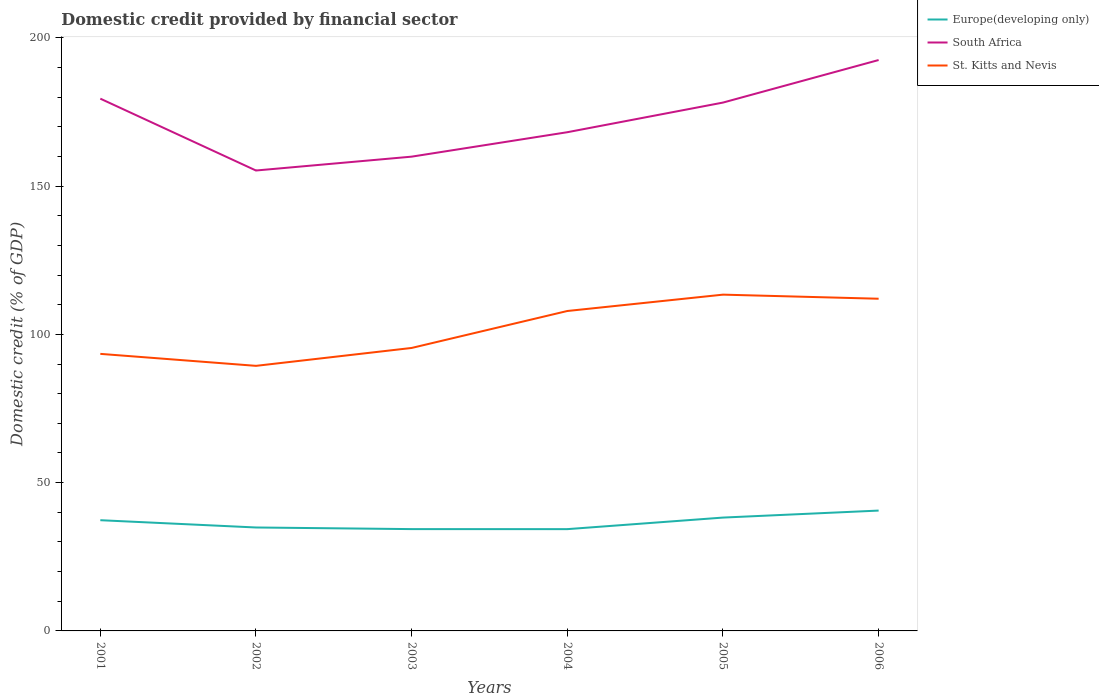Is the number of lines equal to the number of legend labels?
Keep it short and to the point. Yes. Across all years, what is the maximum domestic credit in St. Kitts and Nevis?
Your answer should be very brief. 89.38. What is the total domestic credit in St. Kitts and Nevis in the graph?
Provide a succinct answer. 4.04. What is the difference between the highest and the second highest domestic credit in South Africa?
Your answer should be compact. 37.25. What is the difference between the highest and the lowest domestic credit in Europe(developing only)?
Make the answer very short. 3. Is the domestic credit in Europe(developing only) strictly greater than the domestic credit in St. Kitts and Nevis over the years?
Offer a terse response. Yes. How many years are there in the graph?
Offer a terse response. 6. Are the values on the major ticks of Y-axis written in scientific E-notation?
Your answer should be very brief. No. How many legend labels are there?
Your answer should be compact. 3. What is the title of the graph?
Make the answer very short. Domestic credit provided by financial sector. Does "Niger" appear as one of the legend labels in the graph?
Your answer should be very brief. No. What is the label or title of the X-axis?
Keep it short and to the point. Years. What is the label or title of the Y-axis?
Make the answer very short. Domestic credit (% of GDP). What is the Domestic credit (% of GDP) of Europe(developing only) in 2001?
Your answer should be very brief. 37.33. What is the Domestic credit (% of GDP) of South Africa in 2001?
Offer a terse response. 179.48. What is the Domestic credit (% of GDP) in St. Kitts and Nevis in 2001?
Your response must be concise. 93.42. What is the Domestic credit (% of GDP) in Europe(developing only) in 2002?
Your answer should be very brief. 34.88. What is the Domestic credit (% of GDP) in South Africa in 2002?
Your answer should be compact. 155.25. What is the Domestic credit (% of GDP) in St. Kitts and Nevis in 2002?
Provide a succinct answer. 89.38. What is the Domestic credit (% of GDP) of Europe(developing only) in 2003?
Offer a terse response. 34.33. What is the Domestic credit (% of GDP) in South Africa in 2003?
Make the answer very short. 159.92. What is the Domestic credit (% of GDP) in St. Kitts and Nevis in 2003?
Make the answer very short. 95.42. What is the Domestic credit (% of GDP) in Europe(developing only) in 2004?
Provide a short and direct response. 34.32. What is the Domestic credit (% of GDP) of South Africa in 2004?
Make the answer very short. 168.16. What is the Domestic credit (% of GDP) of St. Kitts and Nevis in 2004?
Offer a terse response. 107.88. What is the Domestic credit (% of GDP) in Europe(developing only) in 2005?
Keep it short and to the point. 38.22. What is the Domestic credit (% of GDP) of South Africa in 2005?
Give a very brief answer. 178.16. What is the Domestic credit (% of GDP) of St. Kitts and Nevis in 2005?
Make the answer very short. 113.39. What is the Domestic credit (% of GDP) of Europe(developing only) in 2006?
Offer a terse response. 40.58. What is the Domestic credit (% of GDP) of South Africa in 2006?
Offer a terse response. 192.5. What is the Domestic credit (% of GDP) of St. Kitts and Nevis in 2006?
Offer a very short reply. 112.01. Across all years, what is the maximum Domestic credit (% of GDP) in Europe(developing only)?
Your answer should be very brief. 40.58. Across all years, what is the maximum Domestic credit (% of GDP) in South Africa?
Provide a short and direct response. 192.5. Across all years, what is the maximum Domestic credit (% of GDP) of St. Kitts and Nevis?
Offer a terse response. 113.39. Across all years, what is the minimum Domestic credit (% of GDP) in Europe(developing only)?
Your answer should be compact. 34.32. Across all years, what is the minimum Domestic credit (% of GDP) of South Africa?
Offer a terse response. 155.25. Across all years, what is the minimum Domestic credit (% of GDP) of St. Kitts and Nevis?
Make the answer very short. 89.38. What is the total Domestic credit (% of GDP) in Europe(developing only) in the graph?
Offer a very short reply. 219.66. What is the total Domestic credit (% of GDP) of South Africa in the graph?
Your response must be concise. 1033.47. What is the total Domestic credit (% of GDP) in St. Kitts and Nevis in the graph?
Make the answer very short. 611.5. What is the difference between the Domestic credit (% of GDP) of Europe(developing only) in 2001 and that in 2002?
Offer a terse response. 2.46. What is the difference between the Domestic credit (% of GDP) of South Africa in 2001 and that in 2002?
Your answer should be very brief. 24.23. What is the difference between the Domestic credit (% of GDP) in St. Kitts and Nevis in 2001 and that in 2002?
Your answer should be compact. 4.04. What is the difference between the Domestic credit (% of GDP) in Europe(developing only) in 2001 and that in 2003?
Your answer should be very brief. 3. What is the difference between the Domestic credit (% of GDP) of South Africa in 2001 and that in 2003?
Offer a very short reply. 19.55. What is the difference between the Domestic credit (% of GDP) in St. Kitts and Nevis in 2001 and that in 2003?
Ensure brevity in your answer.  -1.99. What is the difference between the Domestic credit (% of GDP) in Europe(developing only) in 2001 and that in 2004?
Your answer should be very brief. 3.01. What is the difference between the Domestic credit (% of GDP) of South Africa in 2001 and that in 2004?
Give a very brief answer. 11.32. What is the difference between the Domestic credit (% of GDP) in St. Kitts and Nevis in 2001 and that in 2004?
Offer a very short reply. -14.45. What is the difference between the Domestic credit (% of GDP) of Europe(developing only) in 2001 and that in 2005?
Provide a short and direct response. -0.88. What is the difference between the Domestic credit (% of GDP) in South Africa in 2001 and that in 2005?
Provide a succinct answer. 1.32. What is the difference between the Domestic credit (% of GDP) in St. Kitts and Nevis in 2001 and that in 2005?
Offer a very short reply. -19.97. What is the difference between the Domestic credit (% of GDP) of Europe(developing only) in 2001 and that in 2006?
Your answer should be compact. -3.24. What is the difference between the Domestic credit (% of GDP) of South Africa in 2001 and that in 2006?
Provide a succinct answer. -13.03. What is the difference between the Domestic credit (% of GDP) of St. Kitts and Nevis in 2001 and that in 2006?
Your response must be concise. -18.59. What is the difference between the Domestic credit (% of GDP) in Europe(developing only) in 2002 and that in 2003?
Keep it short and to the point. 0.55. What is the difference between the Domestic credit (% of GDP) of South Africa in 2002 and that in 2003?
Keep it short and to the point. -4.67. What is the difference between the Domestic credit (% of GDP) in St. Kitts and Nevis in 2002 and that in 2003?
Offer a terse response. -6.03. What is the difference between the Domestic credit (% of GDP) of Europe(developing only) in 2002 and that in 2004?
Make the answer very short. 0.56. What is the difference between the Domestic credit (% of GDP) of South Africa in 2002 and that in 2004?
Your answer should be compact. -12.91. What is the difference between the Domestic credit (% of GDP) of St. Kitts and Nevis in 2002 and that in 2004?
Provide a short and direct response. -18.49. What is the difference between the Domestic credit (% of GDP) of Europe(developing only) in 2002 and that in 2005?
Your answer should be very brief. -3.34. What is the difference between the Domestic credit (% of GDP) in South Africa in 2002 and that in 2005?
Offer a very short reply. -22.91. What is the difference between the Domestic credit (% of GDP) in St. Kitts and Nevis in 2002 and that in 2005?
Your answer should be very brief. -24.01. What is the difference between the Domestic credit (% of GDP) of Europe(developing only) in 2002 and that in 2006?
Make the answer very short. -5.7. What is the difference between the Domestic credit (% of GDP) of South Africa in 2002 and that in 2006?
Offer a terse response. -37.25. What is the difference between the Domestic credit (% of GDP) in St. Kitts and Nevis in 2002 and that in 2006?
Offer a terse response. -22.63. What is the difference between the Domestic credit (% of GDP) in Europe(developing only) in 2003 and that in 2004?
Offer a terse response. 0.01. What is the difference between the Domestic credit (% of GDP) of South Africa in 2003 and that in 2004?
Make the answer very short. -8.24. What is the difference between the Domestic credit (% of GDP) in St. Kitts and Nevis in 2003 and that in 2004?
Offer a very short reply. -12.46. What is the difference between the Domestic credit (% of GDP) of Europe(developing only) in 2003 and that in 2005?
Make the answer very short. -3.89. What is the difference between the Domestic credit (% of GDP) in South Africa in 2003 and that in 2005?
Keep it short and to the point. -18.23. What is the difference between the Domestic credit (% of GDP) of St. Kitts and Nevis in 2003 and that in 2005?
Your response must be concise. -17.97. What is the difference between the Domestic credit (% of GDP) of Europe(developing only) in 2003 and that in 2006?
Ensure brevity in your answer.  -6.25. What is the difference between the Domestic credit (% of GDP) in South Africa in 2003 and that in 2006?
Keep it short and to the point. -32.58. What is the difference between the Domestic credit (% of GDP) of St. Kitts and Nevis in 2003 and that in 2006?
Your answer should be very brief. -16.59. What is the difference between the Domestic credit (% of GDP) of Europe(developing only) in 2004 and that in 2005?
Your answer should be very brief. -3.9. What is the difference between the Domestic credit (% of GDP) in South Africa in 2004 and that in 2005?
Keep it short and to the point. -10. What is the difference between the Domestic credit (% of GDP) of St. Kitts and Nevis in 2004 and that in 2005?
Ensure brevity in your answer.  -5.51. What is the difference between the Domestic credit (% of GDP) in Europe(developing only) in 2004 and that in 2006?
Provide a short and direct response. -6.26. What is the difference between the Domestic credit (% of GDP) in South Africa in 2004 and that in 2006?
Provide a short and direct response. -24.34. What is the difference between the Domestic credit (% of GDP) in St. Kitts and Nevis in 2004 and that in 2006?
Your response must be concise. -4.13. What is the difference between the Domestic credit (% of GDP) in Europe(developing only) in 2005 and that in 2006?
Your response must be concise. -2.36. What is the difference between the Domestic credit (% of GDP) in South Africa in 2005 and that in 2006?
Offer a very short reply. -14.35. What is the difference between the Domestic credit (% of GDP) of St. Kitts and Nevis in 2005 and that in 2006?
Your response must be concise. 1.38. What is the difference between the Domestic credit (% of GDP) in Europe(developing only) in 2001 and the Domestic credit (% of GDP) in South Africa in 2002?
Ensure brevity in your answer.  -117.91. What is the difference between the Domestic credit (% of GDP) in Europe(developing only) in 2001 and the Domestic credit (% of GDP) in St. Kitts and Nevis in 2002?
Keep it short and to the point. -52.05. What is the difference between the Domestic credit (% of GDP) of South Africa in 2001 and the Domestic credit (% of GDP) of St. Kitts and Nevis in 2002?
Keep it short and to the point. 90.09. What is the difference between the Domestic credit (% of GDP) in Europe(developing only) in 2001 and the Domestic credit (% of GDP) in South Africa in 2003?
Offer a very short reply. -122.59. What is the difference between the Domestic credit (% of GDP) in Europe(developing only) in 2001 and the Domestic credit (% of GDP) in St. Kitts and Nevis in 2003?
Your answer should be compact. -58.08. What is the difference between the Domestic credit (% of GDP) of South Africa in 2001 and the Domestic credit (% of GDP) of St. Kitts and Nevis in 2003?
Keep it short and to the point. 84.06. What is the difference between the Domestic credit (% of GDP) in Europe(developing only) in 2001 and the Domestic credit (% of GDP) in South Africa in 2004?
Offer a very short reply. -130.83. What is the difference between the Domestic credit (% of GDP) in Europe(developing only) in 2001 and the Domestic credit (% of GDP) in St. Kitts and Nevis in 2004?
Provide a short and direct response. -70.54. What is the difference between the Domestic credit (% of GDP) of South Africa in 2001 and the Domestic credit (% of GDP) of St. Kitts and Nevis in 2004?
Give a very brief answer. 71.6. What is the difference between the Domestic credit (% of GDP) in Europe(developing only) in 2001 and the Domestic credit (% of GDP) in South Africa in 2005?
Keep it short and to the point. -140.82. What is the difference between the Domestic credit (% of GDP) of Europe(developing only) in 2001 and the Domestic credit (% of GDP) of St. Kitts and Nevis in 2005?
Your response must be concise. -76.06. What is the difference between the Domestic credit (% of GDP) in South Africa in 2001 and the Domestic credit (% of GDP) in St. Kitts and Nevis in 2005?
Offer a very short reply. 66.09. What is the difference between the Domestic credit (% of GDP) of Europe(developing only) in 2001 and the Domestic credit (% of GDP) of South Africa in 2006?
Keep it short and to the point. -155.17. What is the difference between the Domestic credit (% of GDP) in Europe(developing only) in 2001 and the Domestic credit (% of GDP) in St. Kitts and Nevis in 2006?
Keep it short and to the point. -74.68. What is the difference between the Domestic credit (% of GDP) of South Africa in 2001 and the Domestic credit (% of GDP) of St. Kitts and Nevis in 2006?
Offer a terse response. 67.47. What is the difference between the Domestic credit (% of GDP) in Europe(developing only) in 2002 and the Domestic credit (% of GDP) in South Africa in 2003?
Your response must be concise. -125.05. What is the difference between the Domestic credit (% of GDP) in Europe(developing only) in 2002 and the Domestic credit (% of GDP) in St. Kitts and Nevis in 2003?
Ensure brevity in your answer.  -60.54. What is the difference between the Domestic credit (% of GDP) in South Africa in 2002 and the Domestic credit (% of GDP) in St. Kitts and Nevis in 2003?
Keep it short and to the point. 59.83. What is the difference between the Domestic credit (% of GDP) in Europe(developing only) in 2002 and the Domestic credit (% of GDP) in South Africa in 2004?
Your answer should be compact. -133.28. What is the difference between the Domestic credit (% of GDP) in Europe(developing only) in 2002 and the Domestic credit (% of GDP) in St. Kitts and Nevis in 2004?
Offer a very short reply. -73. What is the difference between the Domestic credit (% of GDP) in South Africa in 2002 and the Domestic credit (% of GDP) in St. Kitts and Nevis in 2004?
Keep it short and to the point. 47.37. What is the difference between the Domestic credit (% of GDP) in Europe(developing only) in 2002 and the Domestic credit (% of GDP) in South Africa in 2005?
Provide a short and direct response. -143.28. What is the difference between the Domestic credit (% of GDP) of Europe(developing only) in 2002 and the Domestic credit (% of GDP) of St. Kitts and Nevis in 2005?
Provide a short and direct response. -78.51. What is the difference between the Domestic credit (% of GDP) in South Africa in 2002 and the Domestic credit (% of GDP) in St. Kitts and Nevis in 2005?
Your response must be concise. 41.86. What is the difference between the Domestic credit (% of GDP) of Europe(developing only) in 2002 and the Domestic credit (% of GDP) of South Africa in 2006?
Make the answer very short. -157.63. What is the difference between the Domestic credit (% of GDP) in Europe(developing only) in 2002 and the Domestic credit (% of GDP) in St. Kitts and Nevis in 2006?
Your answer should be very brief. -77.13. What is the difference between the Domestic credit (% of GDP) in South Africa in 2002 and the Domestic credit (% of GDP) in St. Kitts and Nevis in 2006?
Your answer should be compact. 43.24. What is the difference between the Domestic credit (% of GDP) of Europe(developing only) in 2003 and the Domestic credit (% of GDP) of South Africa in 2004?
Your answer should be compact. -133.83. What is the difference between the Domestic credit (% of GDP) in Europe(developing only) in 2003 and the Domestic credit (% of GDP) in St. Kitts and Nevis in 2004?
Provide a short and direct response. -73.54. What is the difference between the Domestic credit (% of GDP) of South Africa in 2003 and the Domestic credit (% of GDP) of St. Kitts and Nevis in 2004?
Make the answer very short. 52.05. What is the difference between the Domestic credit (% of GDP) of Europe(developing only) in 2003 and the Domestic credit (% of GDP) of South Africa in 2005?
Give a very brief answer. -143.82. What is the difference between the Domestic credit (% of GDP) of Europe(developing only) in 2003 and the Domestic credit (% of GDP) of St. Kitts and Nevis in 2005?
Offer a very short reply. -79.06. What is the difference between the Domestic credit (% of GDP) of South Africa in 2003 and the Domestic credit (% of GDP) of St. Kitts and Nevis in 2005?
Offer a very short reply. 46.53. What is the difference between the Domestic credit (% of GDP) of Europe(developing only) in 2003 and the Domestic credit (% of GDP) of South Africa in 2006?
Make the answer very short. -158.17. What is the difference between the Domestic credit (% of GDP) in Europe(developing only) in 2003 and the Domestic credit (% of GDP) in St. Kitts and Nevis in 2006?
Provide a succinct answer. -77.68. What is the difference between the Domestic credit (% of GDP) in South Africa in 2003 and the Domestic credit (% of GDP) in St. Kitts and Nevis in 2006?
Keep it short and to the point. 47.91. What is the difference between the Domestic credit (% of GDP) of Europe(developing only) in 2004 and the Domestic credit (% of GDP) of South Africa in 2005?
Keep it short and to the point. -143.84. What is the difference between the Domestic credit (% of GDP) in Europe(developing only) in 2004 and the Domestic credit (% of GDP) in St. Kitts and Nevis in 2005?
Give a very brief answer. -79.07. What is the difference between the Domestic credit (% of GDP) of South Africa in 2004 and the Domestic credit (% of GDP) of St. Kitts and Nevis in 2005?
Provide a short and direct response. 54.77. What is the difference between the Domestic credit (% of GDP) of Europe(developing only) in 2004 and the Domestic credit (% of GDP) of South Africa in 2006?
Offer a terse response. -158.18. What is the difference between the Domestic credit (% of GDP) of Europe(developing only) in 2004 and the Domestic credit (% of GDP) of St. Kitts and Nevis in 2006?
Provide a short and direct response. -77.69. What is the difference between the Domestic credit (% of GDP) in South Africa in 2004 and the Domestic credit (% of GDP) in St. Kitts and Nevis in 2006?
Keep it short and to the point. 56.15. What is the difference between the Domestic credit (% of GDP) in Europe(developing only) in 2005 and the Domestic credit (% of GDP) in South Africa in 2006?
Give a very brief answer. -154.28. What is the difference between the Domestic credit (% of GDP) of Europe(developing only) in 2005 and the Domestic credit (% of GDP) of St. Kitts and Nevis in 2006?
Offer a terse response. -73.79. What is the difference between the Domestic credit (% of GDP) of South Africa in 2005 and the Domestic credit (% of GDP) of St. Kitts and Nevis in 2006?
Offer a very short reply. 66.15. What is the average Domestic credit (% of GDP) in Europe(developing only) per year?
Keep it short and to the point. 36.61. What is the average Domestic credit (% of GDP) of South Africa per year?
Keep it short and to the point. 172.24. What is the average Domestic credit (% of GDP) in St. Kitts and Nevis per year?
Provide a short and direct response. 101.92. In the year 2001, what is the difference between the Domestic credit (% of GDP) in Europe(developing only) and Domestic credit (% of GDP) in South Africa?
Provide a succinct answer. -142.14. In the year 2001, what is the difference between the Domestic credit (% of GDP) in Europe(developing only) and Domestic credit (% of GDP) in St. Kitts and Nevis?
Give a very brief answer. -56.09. In the year 2001, what is the difference between the Domestic credit (% of GDP) of South Africa and Domestic credit (% of GDP) of St. Kitts and Nevis?
Your answer should be very brief. 86.05. In the year 2002, what is the difference between the Domestic credit (% of GDP) in Europe(developing only) and Domestic credit (% of GDP) in South Africa?
Keep it short and to the point. -120.37. In the year 2002, what is the difference between the Domestic credit (% of GDP) in Europe(developing only) and Domestic credit (% of GDP) in St. Kitts and Nevis?
Provide a succinct answer. -54.5. In the year 2002, what is the difference between the Domestic credit (% of GDP) in South Africa and Domestic credit (% of GDP) in St. Kitts and Nevis?
Ensure brevity in your answer.  65.87. In the year 2003, what is the difference between the Domestic credit (% of GDP) in Europe(developing only) and Domestic credit (% of GDP) in South Africa?
Your answer should be compact. -125.59. In the year 2003, what is the difference between the Domestic credit (% of GDP) in Europe(developing only) and Domestic credit (% of GDP) in St. Kitts and Nevis?
Make the answer very short. -61.08. In the year 2003, what is the difference between the Domestic credit (% of GDP) in South Africa and Domestic credit (% of GDP) in St. Kitts and Nevis?
Your response must be concise. 64.51. In the year 2004, what is the difference between the Domestic credit (% of GDP) of Europe(developing only) and Domestic credit (% of GDP) of South Africa?
Provide a short and direct response. -133.84. In the year 2004, what is the difference between the Domestic credit (% of GDP) of Europe(developing only) and Domestic credit (% of GDP) of St. Kitts and Nevis?
Your answer should be compact. -73.56. In the year 2004, what is the difference between the Domestic credit (% of GDP) in South Africa and Domestic credit (% of GDP) in St. Kitts and Nevis?
Your answer should be compact. 60.28. In the year 2005, what is the difference between the Domestic credit (% of GDP) in Europe(developing only) and Domestic credit (% of GDP) in South Africa?
Your response must be concise. -139.94. In the year 2005, what is the difference between the Domestic credit (% of GDP) of Europe(developing only) and Domestic credit (% of GDP) of St. Kitts and Nevis?
Keep it short and to the point. -75.17. In the year 2005, what is the difference between the Domestic credit (% of GDP) in South Africa and Domestic credit (% of GDP) in St. Kitts and Nevis?
Make the answer very short. 64.77. In the year 2006, what is the difference between the Domestic credit (% of GDP) of Europe(developing only) and Domestic credit (% of GDP) of South Africa?
Your answer should be compact. -151.92. In the year 2006, what is the difference between the Domestic credit (% of GDP) of Europe(developing only) and Domestic credit (% of GDP) of St. Kitts and Nevis?
Your response must be concise. -71.43. In the year 2006, what is the difference between the Domestic credit (% of GDP) of South Africa and Domestic credit (% of GDP) of St. Kitts and Nevis?
Offer a very short reply. 80.49. What is the ratio of the Domestic credit (% of GDP) in Europe(developing only) in 2001 to that in 2002?
Make the answer very short. 1.07. What is the ratio of the Domestic credit (% of GDP) in South Africa in 2001 to that in 2002?
Keep it short and to the point. 1.16. What is the ratio of the Domestic credit (% of GDP) in St. Kitts and Nevis in 2001 to that in 2002?
Keep it short and to the point. 1.05. What is the ratio of the Domestic credit (% of GDP) in Europe(developing only) in 2001 to that in 2003?
Make the answer very short. 1.09. What is the ratio of the Domestic credit (% of GDP) in South Africa in 2001 to that in 2003?
Your response must be concise. 1.12. What is the ratio of the Domestic credit (% of GDP) in St. Kitts and Nevis in 2001 to that in 2003?
Your answer should be compact. 0.98. What is the ratio of the Domestic credit (% of GDP) of Europe(developing only) in 2001 to that in 2004?
Provide a succinct answer. 1.09. What is the ratio of the Domestic credit (% of GDP) of South Africa in 2001 to that in 2004?
Keep it short and to the point. 1.07. What is the ratio of the Domestic credit (% of GDP) of St. Kitts and Nevis in 2001 to that in 2004?
Provide a short and direct response. 0.87. What is the ratio of the Domestic credit (% of GDP) of Europe(developing only) in 2001 to that in 2005?
Offer a terse response. 0.98. What is the ratio of the Domestic credit (% of GDP) in South Africa in 2001 to that in 2005?
Provide a succinct answer. 1.01. What is the ratio of the Domestic credit (% of GDP) in St. Kitts and Nevis in 2001 to that in 2005?
Give a very brief answer. 0.82. What is the ratio of the Domestic credit (% of GDP) in Europe(developing only) in 2001 to that in 2006?
Offer a very short reply. 0.92. What is the ratio of the Domestic credit (% of GDP) of South Africa in 2001 to that in 2006?
Your answer should be compact. 0.93. What is the ratio of the Domestic credit (% of GDP) of St. Kitts and Nevis in 2001 to that in 2006?
Give a very brief answer. 0.83. What is the ratio of the Domestic credit (% of GDP) in Europe(developing only) in 2002 to that in 2003?
Make the answer very short. 1.02. What is the ratio of the Domestic credit (% of GDP) in South Africa in 2002 to that in 2003?
Your answer should be compact. 0.97. What is the ratio of the Domestic credit (% of GDP) of St. Kitts and Nevis in 2002 to that in 2003?
Provide a short and direct response. 0.94. What is the ratio of the Domestic credit (% of GDP) in Europe(developing only) in 2002 to that in 2004?
Offer a terse response. 1.02. What is the ratio of the Domestic credit (% of GDP) of South Africa in 2002 to that in 2004?
Offer a very short reply. 0.92. What is the ratio of the Domestic credit (% of GDP) of St. Kitts and Nevis in 2002 to that in 2004?
Provide a succinct answer. 0.83. What is the ratio of the Domestic credit (% of GDP) in Europe(developing only) in 2002 to that in 2005?
Your answer should be compact. 0.91. What is the ratio of the Domestic credit (% of GDP) in South Africa in 2002 to that in 2005?
Ensure brevity in your answer.  0.87. What is the ratio of the Domestic credit (% of GDP) in St. Kitts and Nevis in 2002 to that in 2005?
Keep it short and to the point. 0.79. What is the ratio of the Domestic credit (% of GDP) of Europe(developing only) in 2002 to that in 2006?
Provide a succinct answer. 0.86. What is the ratio of the Domestic credit (% of GDP) in South Africa in 2002 to that in 2006?
Your answer should be compact. 0.81. What is the ratio of the Domestic credit (% of GDP) in St. Kitts and Nevis in 2002 to that in 2006?
Give a very brief answer. 0.8. What is the ratio of the Domestic credit (% of GDP) in South Africa in 2003 to that in 2004?
Your answer should be very brief. 0.95. What is the ratio of the Domestic credit (% of GDP) in St. Kitts and Nevis in 2003 to that in 2004?
Make the answer very short. 0.88. What is the ratio of the Domestic credit (% of GDP) of Europe(developing only) in 2003 to that in 2005?
Offer a terse response. 0.9. What is the ratio of the Domestic credit (% of GDP) in South Africa in 2003 to that in 2005?
Provide a short and direct response. 0.9. What is the ratio of the Domestic credit (% of GDP) in St. Kitts and Nevis in 2003 to that in 2005?
Offer a very short reply. 0.84. What is the ratio of the Domestic credit (% of GDP) in Europe(developing only) in 2003 to that in 2006?
Provide a short and direct response. 0.85. What is the ratio of the Domestic credit (% of GDP) in South Africa in 2003 to that in 2006?
Make the answer very short. 0.83. What is the ratio of the Domestic credit (% of GDP) of St. Kitts and Nevis in 2003 to that in 2006?
Give a very brief answer. 0.85. What is the ratio of the Domestic credit (% of GDP) in Europe(developing only) in 2004 to that in 2005?
Make the answer very short. 0.9. What is the ratio of the Domestic credit (% of GDP) of South Africa in 2004 to that in 2005?
Provide a short and direct response. 0.94. What is the ratio of the Domestic credit (% of GDP) in St. Kitts and Nevis in 2004 to that in 2005?
Give a very brief answer. 0.95. What is the ratio of the Domestic credit (% of GDP) of Europe(developing only) in 2004 to that in 2006?
Offer a very short reply. 0.85. What is the ratio of the Domestic credit (% of GDP) of South Africa in 2004 to that in 2006?
Make the answer very short. 0.87. What is the ratio of the Domestic credit (% of GDP) in St. Kitts and Nevis in 2004 to that in 2006?
Your answer should be compact. 0.96. What is the ratio of the Domestic credit (% of GDP) of Europe(developing only) in 2005 to that in 2006?
Your response must be concise. 0.94. What is the ratio of the Domestic credit (% of GDP) in South Africa in 2005 to that in 2006?
Your answer should be very brief. 0.93. What is the ratio of the Domestic credit (% of GDP) of St. Kitts and Nevis in 2005 to that in 2006?
Ensure brevity in your answer.  1.01. What is the difference between the highest and the second highest Domestic credit (% of GDP) of Europe(developing only)?
Offer a terse response. 2.36. What is the difference between the highest and the second highest Domestic credit (% of GDP) of South Africa?
Provide a short and direct response. 13.03. What is the difference between the highest and the second highest Domestic credit (% of GDP) in St. Kitts and Nevis?
Ensure brevity in your answer.  1.38. What is the difference between the highest and the lowest Domestic credit (% of GDP) of Europe(developing only)?
Give a very brief answer. 6.26. What is the difference between the highest and the lowest Domestic credit (% of GDP) in South Africa?
Your response must be concise. 37.25. What is the difference between the highest and the lowest Domestic credit (% of GDP) of St. Kitts and Nevis?
Provide a short and direct response. 24.01. 